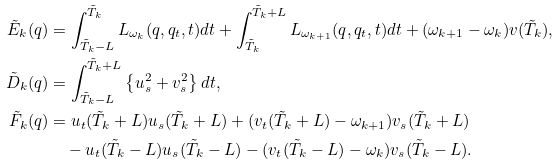<formula> <loc_0><loc_0><loc_500><loc_500>\tilde { E } _ { k } ( q ) & = \int _ { \tilde { T } _ { k } - L } ^ { \tilde { T } _ { k } } L _ { \omega _ { k } } ( q , q _ { t } , t ) d t + \int _ { \tilde { T } _ { k } } ^ { \tilde { T } _ { k } + L } L _ { \omega _ { k + 1 } } ( q , q _ { t } , t ) d t + ( \omega _ { k + 1 } - \omega _ { k } ) v ( \tilde { T } _ { k } ) , \\ \tilde { D } _ { k } ( q ) & = \int _ { \tilde { T } _ { k } - L } ^ { \tilde { T } _ { k } + L } \left \{ u _ { s } ^ { 2 } + v _ { s } ^ { 2 } \right \} d t , \\ \tilde { F } _ { k } ( q ) & = u _ { t } ( \tilde { T } _ { k } + L ) u _ { s } ( \tilde { T } _ { k } + L ) + ( v _ { t } ( \tilde { T } _ { k } + L ) - \omega _ { k + 1 } ) v _ { s } ( \tilde { T } _ { k } + L ) \\ & \quad - u _ { t } ( \tilde { T } _ { k } - L ) u _ { s } ( \tilde { T } _ { k } - L ) - ( v _ { t } ( \tilde { T } _ { k } - L ) - \omega _ { k } ) v _ { s } ( \tilde { T } _ { k } - L ) .</formula> 